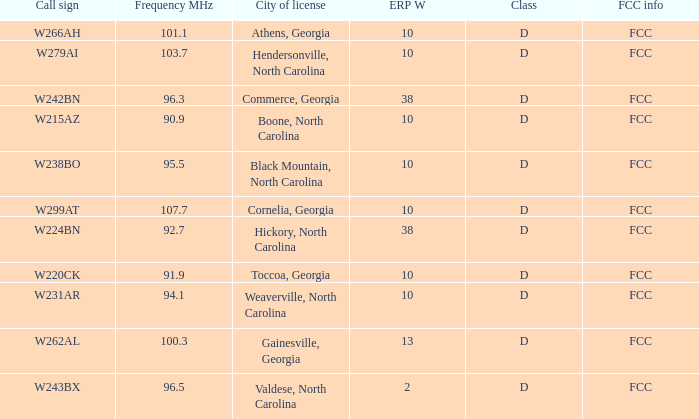What class is the city of black mountain, north carolina? D. Parse the full table. {'header': ['Call sign', 'Frequency MHz', 'City of license', 'ERP W', 'Class', 'FCC info'], 'rows': [['W266AH', '101.1', 'Athens, Georgia', '10', 'D', 'FCC'], ['W279AI', '103.7', 'Hendersonville, North Carolina', '10', 'D', 'FCC'], ['W242BN', '96.3', 'Commerce, Georgia', '38', 'D', 'FCC'], ['W215AZ', '90.9', 'Boone, North Carolina', '10', 'D', 'FCC'], ['W238BO', '95.5', 'Black Mountain, North Carolina', '10', 'D', 'FCC'], ['W299AT', '107.7', 'Cornelia, Georgia', '10', 'D', 'FCC'], ['W224BN', '92.7', 'Hickory, North Carolina', '38', 'D', 'FCC'], ['W220CK', '91.9', 'Toccoa, Georgia', '10', 'D', 'FCC'], ['W231AR', '94.1', 'Weaverville, North Carolina', '10', 'D', 'FCC'], ['W262AL', '100.3', 'Gainesville, Georgia', '13', 'D', 'FCC'], ['W243BX', '96.5', 'Valdese, North Carolina', '2', 'D', 'FCC']]} 